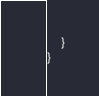<code> <loc_0><loc_0><loc_500><loc_500><_C#_>    }
}
</code> 